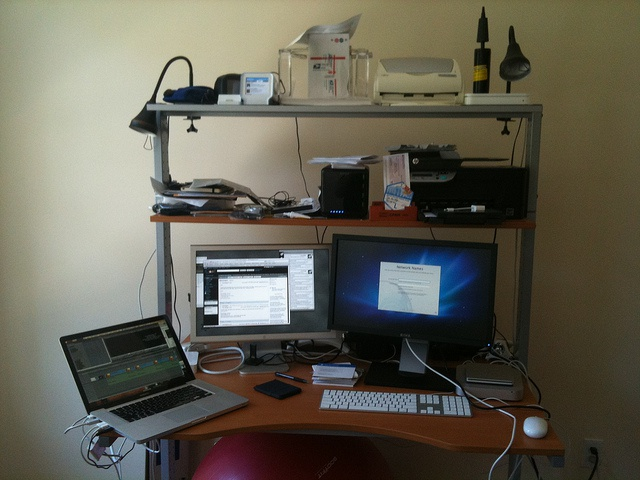Describe the objects in this image and their specific colors. I can see tv in gray, black, navy, darkgray, and blue tones, laptop in gray, black, and darkgreen tones, tv in gray, lightgray, and black tones, chair in gray, black, maroon, and purple tones, and keyboard in gray, darkgray, and black tones in this image. 